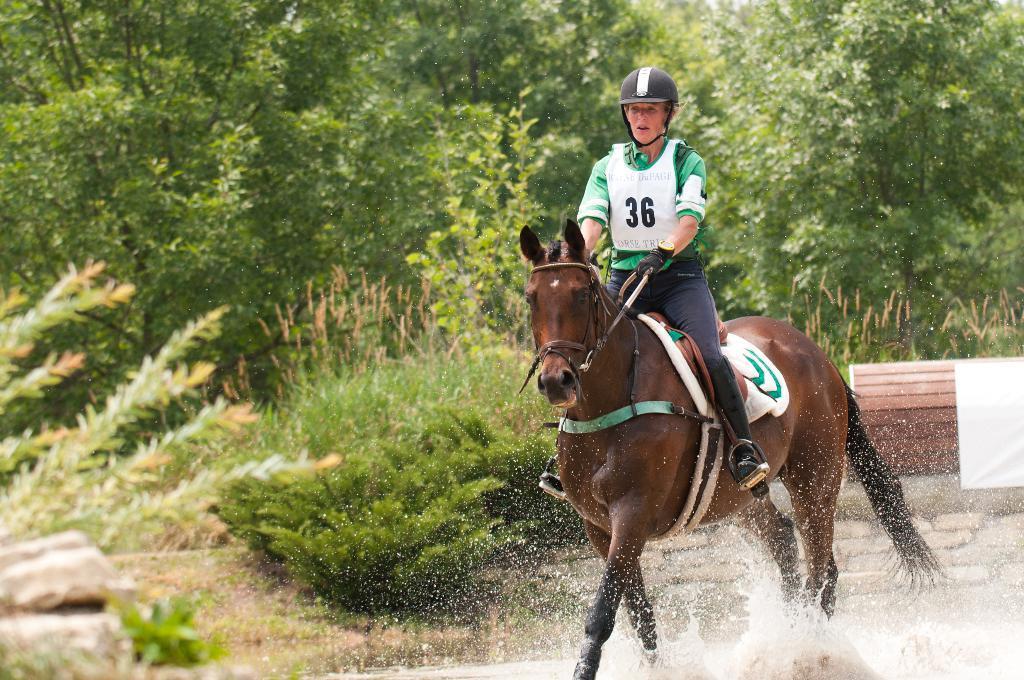Could you give a brief overview of what you see in this image? In this picture we can see a person wearing a helmet, shoes and riding a horse. At the bottom portion of the picture we can see water. In the background we can see trees and plants. On the right side of the picture we can see the wall and a white object. 